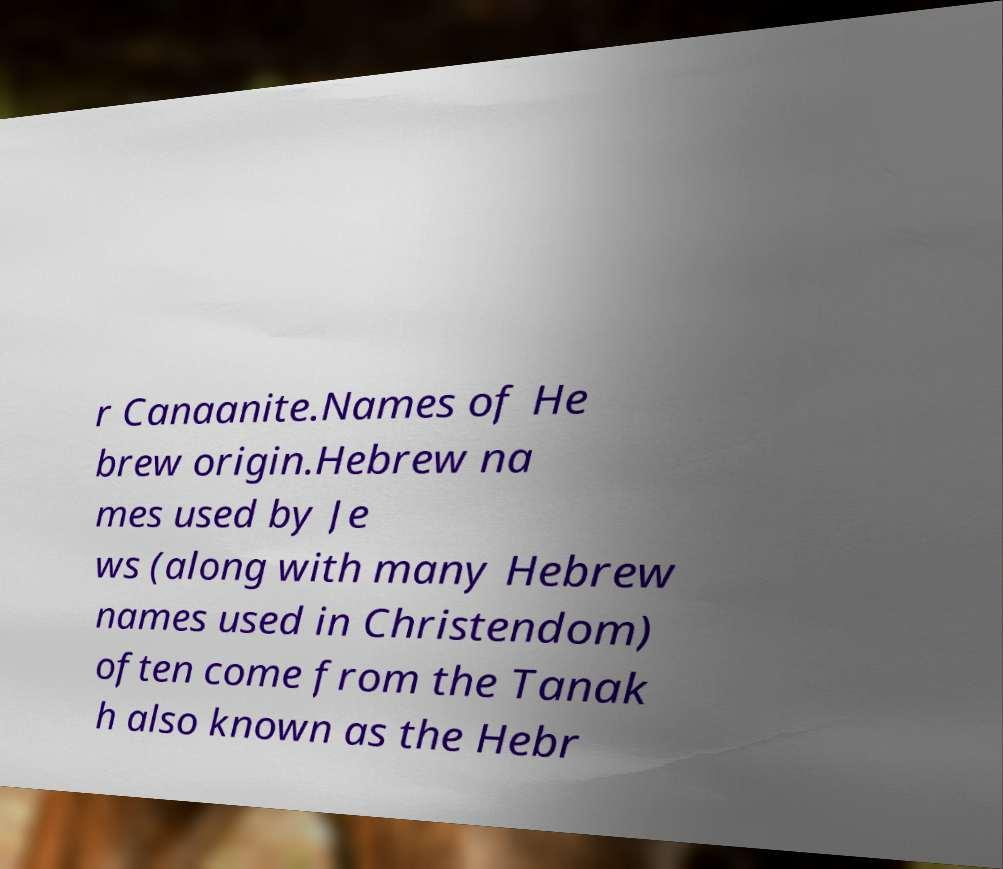Please read and relay the text visible in this image. What does it say? r Canaanite.Names of He brew origin.Hebrew na mes used by Je ws (along with many Hebrew names used in Christendom) often come from the Tanak h also known as the Hebr 